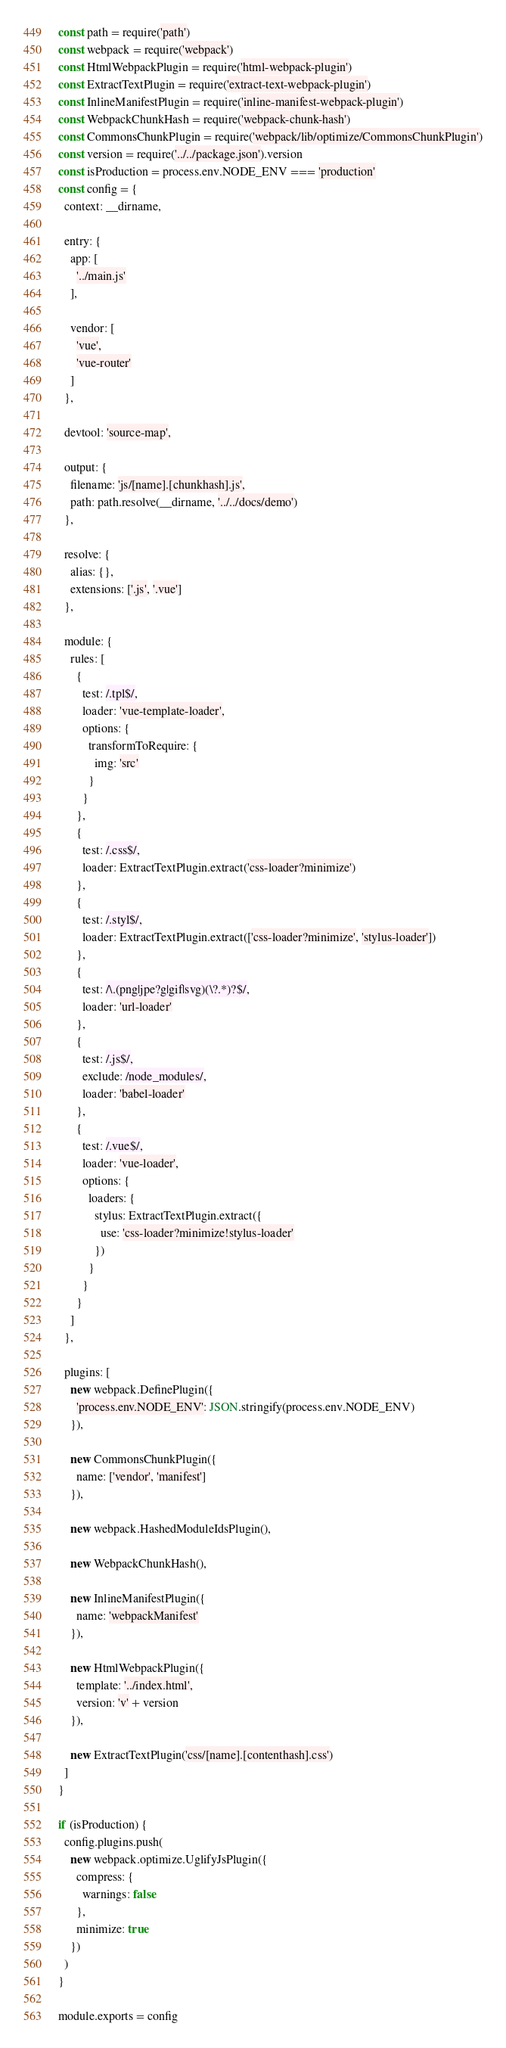<code> <loc_0><loc_0><loc_500><loc_500><_JavaScript_>const path = require('path')
const webpack = require('webpack')
const HtmlWebpackPlugin = require('html-webpack-plugin')
const ExtractTextPlugin = require('extract-text-webpack-plugin')
const InlineManifestPlugin = require('inline-manifest-webpack-plugin')
const WebpackChunkHash = require('webpack-chunk-hash')
const CommonsChunkPlugin = require('webpack/lib/optimize/CommonsChunkPlugin')
const version = require('../../package.json').version
const isProduction = process.env.NODE_ENV === 'production'
const config = {
  context: __dirname,

  entry: {
    app: [
      '../main.js'
    ],

    vendor: [
      'vue',
      'vue-router'
    ]
  },

  devtool: 'source-map',

  output: {
    filename: 'js/[name].[chunkhash].js',
    path: path.resolve(__dirname, '../../docs/demo')
  },

  resolve: {
    alias: {},
    extensions: ['.js', '.vue']
  },

  module: {
    rules: [
      {
        test: /.tpl$/,
        loader: 'vue-template-loader',
        options: {
          transformToRequire: {
            img: 'src'
          }
        }
      },
      {
        test: /.css$/,
        loader: ExtractTextPlugin.extract('css-loader?minimize')
      },
      {
        test: /.styl$/,
        loader: ExtractTextPlugin.extract(['css-loader?minimize', 'stylus-loader'])
      },
      {
        test: /\.(png|jpe?g|gif|svg)(\?.*)?$/,
        loader: 'url-loader'
      },
      {
        test: /.js$/,
        exclude: /node_modules/,
        loader: 'babel-loader'
      },
      {
        test: /.vue$/,
        loader: 'vue-loader',
        options: {
          loaders: {
            stylus: ExtractTextPlugin.extract({
              use: 'css-loader?minimize!stylus-loader'
            })
          }
        }
      }
    ]
  },

  plugins: [
    new webpack.DefinePlugin({
      'process.env.NODE_ENV': JSON.stringify(process.env.NODE_ENV)
    }),

    new CommonsChunkPlugin({
      name: ['vendor', 'manifest']
    }),

    new webpack.HashedModuleIdsPlugin(),

    new WebpackChunkHash(),

    new InlineManifestPlugin({
      name: 'webpackManifest'
    }),

    new HtmlWebpackPlugin({
      template: '../index.html',
      version: 'v' + version
    }),

    new ExtractTextPlugin('css/[name].[contenthash].css')
  ]
}

if (isProduction) {
  config.plugins.push(
    new webpack.optimize.UglifyJsPlugin({
      compress: {
        warnings: false
      },
      minimize: true
    })
  )
}

module.exports = config
</code> 